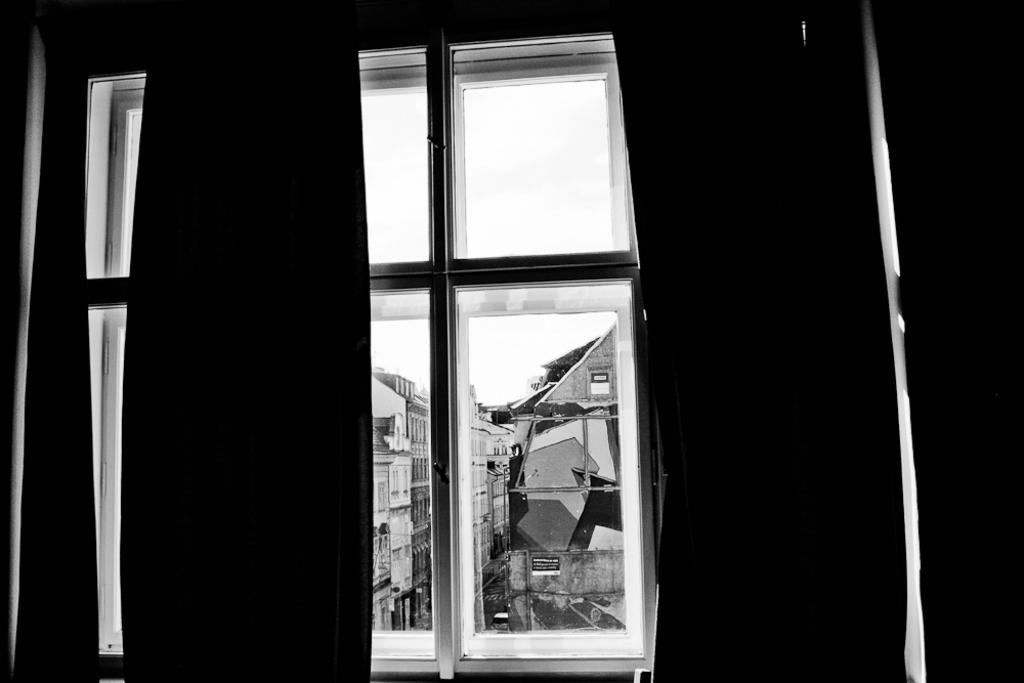What is the color scheme of the image? The image is black and white. What is located on the wall in the image? There is a window in the image. What can be seen through the window? Buildings are visible through the window. What is on the road in the image? There is a vehicle on the road in the image. What is visible at the top of the image? The sky is visible at the top of the image. What does the brother say about the picture in the image? There is no brother or picture present in the image. How many teeth can be seen in the mouth of the person in the image? There is no person or mouth visible in the image. 